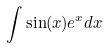Convert formula to latex. <formula><loc_0><loc_0><loc_500><loc_500>\int \sin ( x ) e ^ { x } d x</formula> 